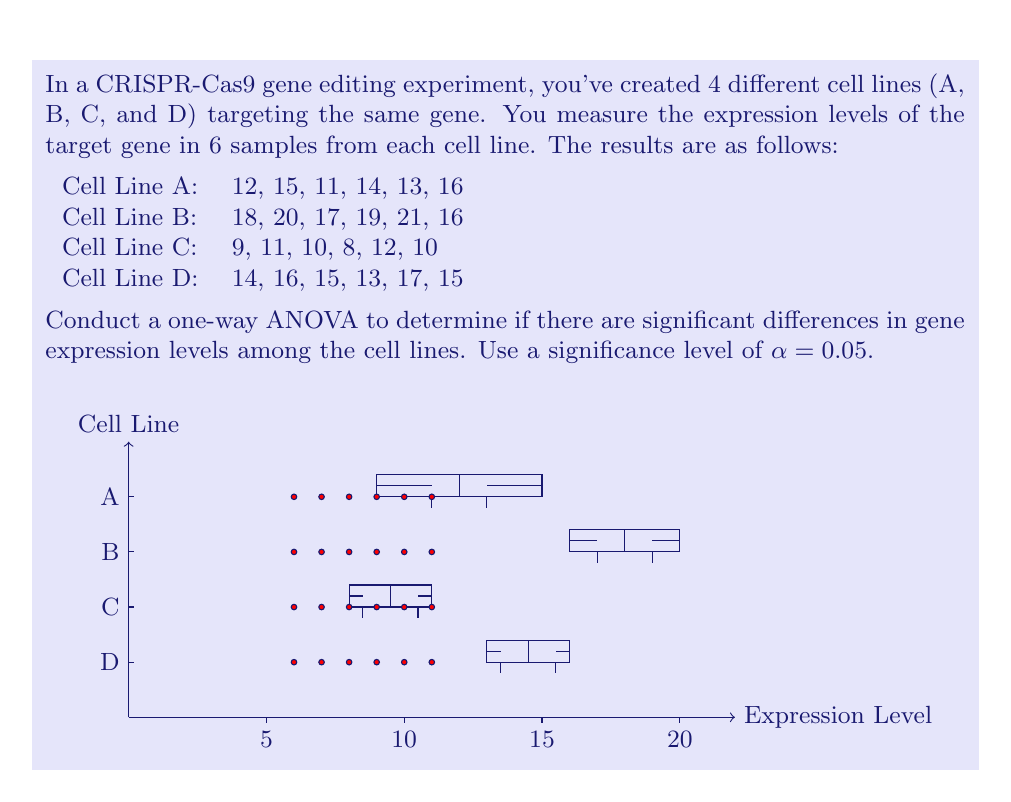Give your solution to this math problem. To conduct a one-way ANOVA, we'll follow these steps:

1. Calculate the overall mean and group means:
   Overall mean = $\frac{(12+15+11+...+15)}{24} = 14.125$
   Mean A = 13.5, Mean B = 18.5, Mean C = 10, Mean D = 15

2. Calculate the Sum of Squares Between groups (SSB):
   $$SSB = \sum_{i=1}^k n_i(\bar{X_i} - \bar{X})^2$$
   where $k$ is the number of groups, $n_i$ is the number of samples in each group, $\bar{X_i}$ is the group mean, and $\bar{X}$ is the overall mean.
   
   $$SSB = 6[(13.5 - 14.125)^2 + (18.5 - 14.125)^2 + (10 - 14.125)^2 + (15 - 14.125)^2] = 270.125$$

3. Calculate the Sum of Squares Within groups (SSW):
   $$SSW = \sum_{i=1}^k \sum_{j=1}^{n_i} (X_{ij} - \bar{X_i})^2$$
   where $X_{ij}$ is each individual observation.
   
   $$SSW = [(12-13.5)^2 + (15-13.5)^2 + ... + (15-15)^2] = 78.5$$

4. Calculate the Total Sum of Squares (SST):
   $$SST = SSB + SSW = 270.125 + 78.5 = 348.625$$

5. Calculate the degrees of freedom:
   df_between = k - 1 = 4 - 1 = 3
   df_within = N - k = 24 - 4 = 20
   df_total = N - 1 = 24 - 1 = 23

6. Calculate Mean Squares:
   $$MS_B = \frac{SSB}{df_B} = \frac{270.125}{3} = 90.042$$
   $$MS_W = \frac{SSW}{df_W} = \frac{78.5}{20} = 3.925$$

7. Calculate the F-statistic:
   $$F = \frac{MS_B}{MS_W} = \frac{90.042}{3.925} = 22.94$$

8. Find the critical F-value:
   For α = 0.05, df_B = 3, and df_W = 20, the critical F-value is approximately 3.10.

9. Compare the calculated F-statistic to the critical F-value:
   Since 22.94 > 3.10, we reject the null hypothesis.

Therefore, we conclude that there are significant differences in gene expression levels among the CRISPR-Cas9 edited cell lines at the 0.05 significance level.
Answer: F(3,20) = 22.94, p < 0.05. Significant differences exist. 